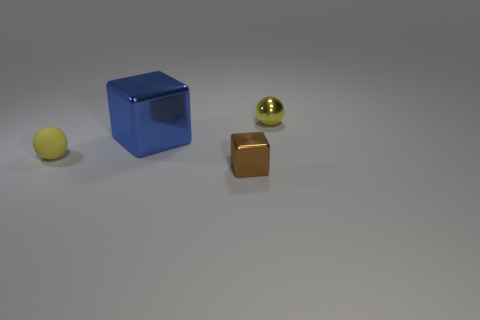There is a ball to the left of the metal ball; is its color the same as the thing that is in front of the matte sphere?
Your answer should be very brief. No. What number of things are to the right of the blue shiny thing and behind the tiny brown cube?
Make the answer very short. 1. There is a blue thing that is the same material as the tiny brown cube; what is its size?
Keep it short and to the point. Large. What size is the blue metallic cube?
Provide a short and direct response. Large. What is the material of the big blue object?
Ensure brevity in your answer.  Metal. Do the ball behind the yellow rubber sphere and the blue shiny block have the same size?
Keep it short and to the point. No. What number of things are either tiny rubber objects or yellow metallic balls?
Provide a short and direct response. 2. What is the shape of the tiny metal object that is the same color as the small rubber object?
Your answer should be compact. Sphere. There is a thing that is both in front of the blue object and to the right of the blue metal thing; what is its size?
Offer a very short reply. Small. Are there an equal number of objects and small brown metallic blocks?
Provide a succinct answer. No. 